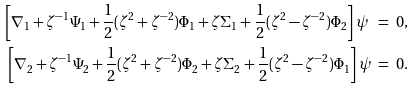<formula> <loc_0><loc_0><loc_500><loc_500>\left [ \nabla _ { 1 } + \zeta ^ { - 1 } \Psi _ { 1 } + \frac { 1 } { 2 } ( \zeta ^ { 2 } + \zeta ^ { - 2 } ) \Phi _ { 1 } + \zeta \Sigma _ { 1 } + \frac { 1 } { 2 } ( \zeta ^ { 2 } - \zeta ^ { - 2 } ) \Phi _ { 2 } \right ] \psi \ & = \ 0 , \\ \left [ \nabla _ { 2 } + \zeta ^ { - 1 } \Psi _ { 2 } + \frac { 1 } { 2 } ( \zeta ^ { 2 } + \zeta ^ { - 2 } ) \Phi _ { 2 } + \zeta \Sigma _ { 2 } + \frac { 1 } { 2 } ( \zeta ^ { 2 } - \zeta ^ { - 2 } ) \Phi _ { 1 } \right ] \psi \ & = \ 0 . \\</formula> 